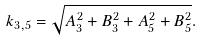Convert formula to latex. <formula><loc_0><loc_0><loc_500><loc_500>k _ { 3 , 5 } = \sqrt { A _ { 3 } ^ { 2 } + B _ { 3 } ^ { 2 } + A _ { 5 } ^ { 2 } + B _ { 5 } ^ { 2 } } .</formula> 